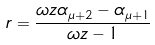<formula> <loc_0><loc_0><loc_500><loc_500>r = \frac { \omega z \alpha _ { \mu + 2 } - \alpha _ { \mu + 1 } } { \omega z - 1 }</formula> 